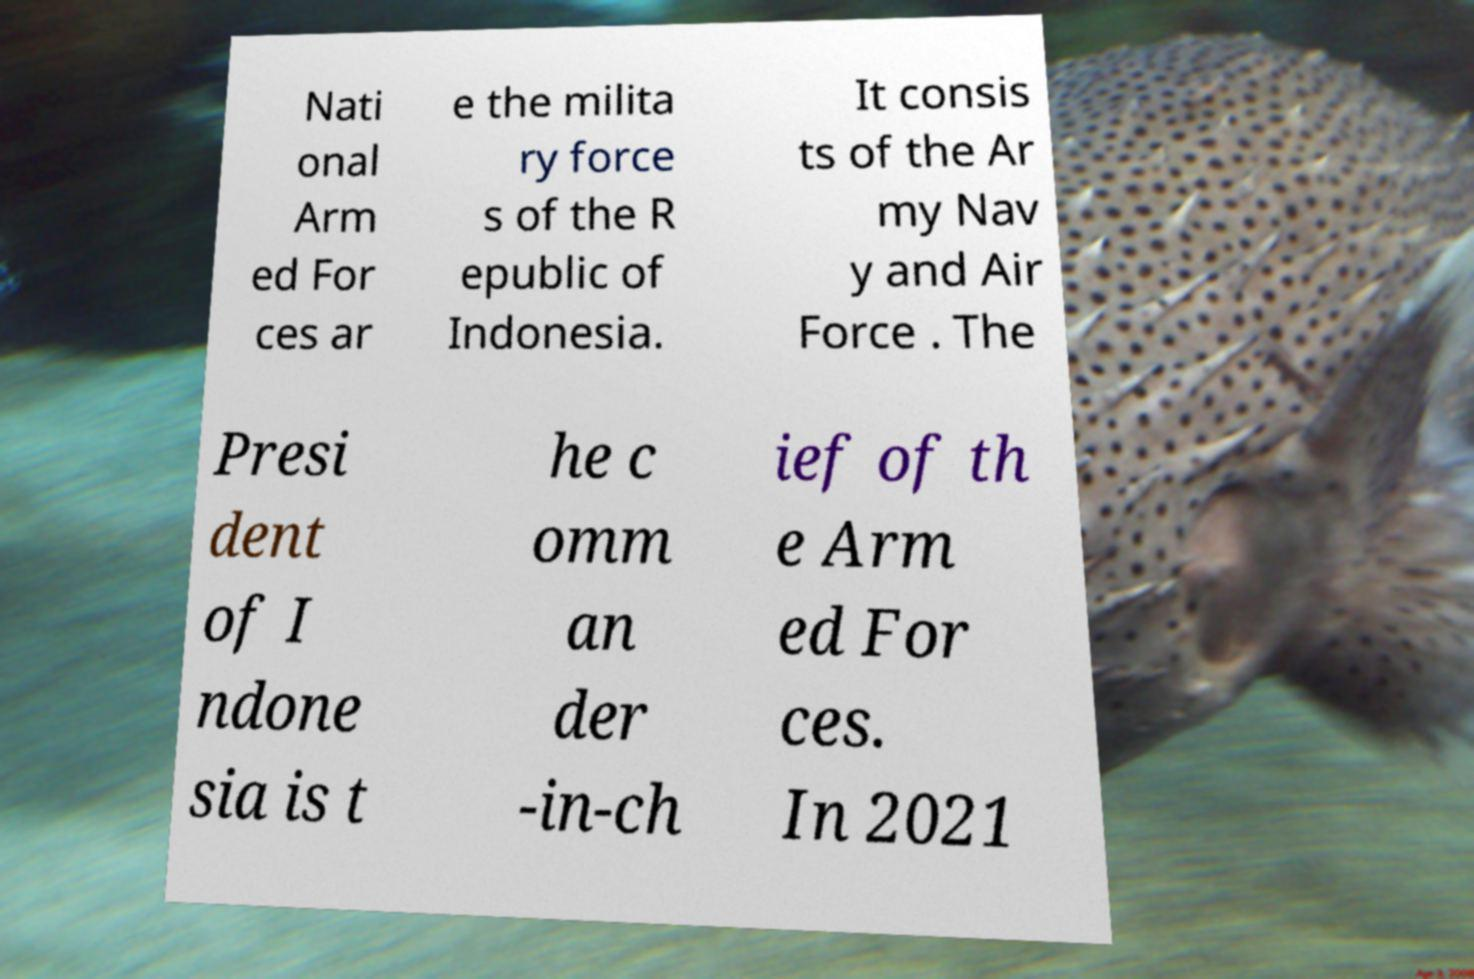I need the written content from this picture converted into text. Can you do that? Nati onal Arm ed For ces ar e the milita ry force s of the R epublic of Indonesia. It consis ts of the Ar my Nav y and Air Force . The Presi dent of I ndone sia is t he c omm an der -in-ch ief of th e Arm ed For ces. In 2021 